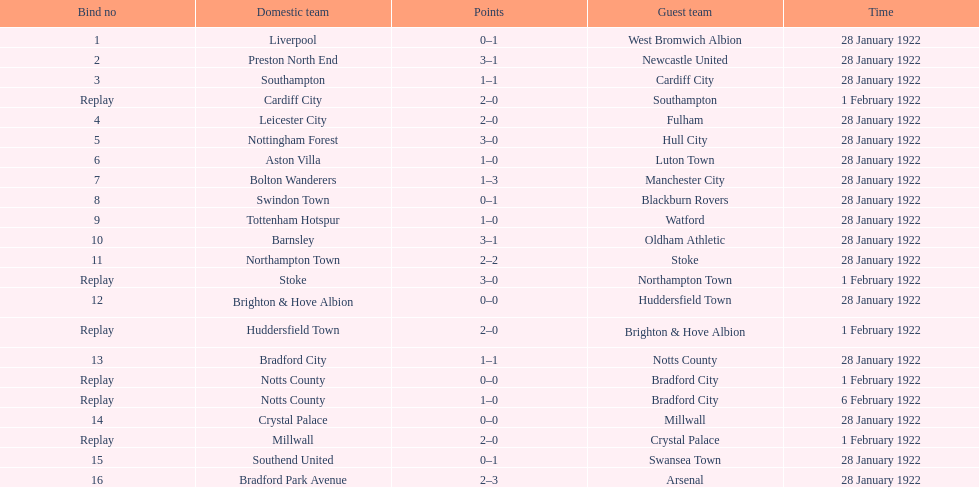What was the score in the aston villa game? 1–0. Which other team had an identical score? Tottenham Hotspur. 